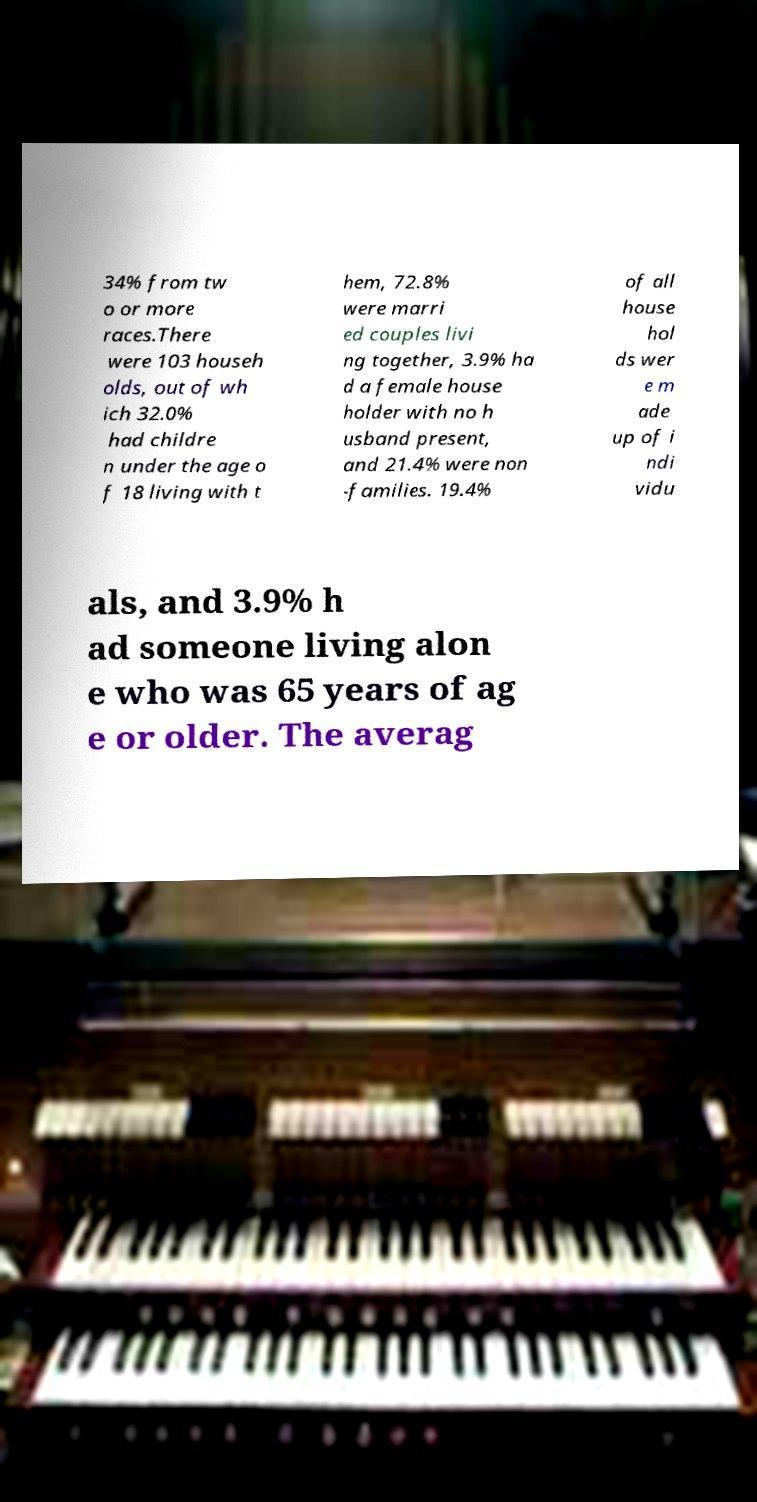Please read and relay the text visible in this image. What does it say? 34% from tw o or more races.There were 103 househ olds, out of wh ich 32.0% had childre n under the age o f 18 living with t hem, 72.8% were marri ed couples livi ng together, 3.9% ha d a female house holder with no h usband present, and 21.4% were non -families. 19.4% of all house hol ds wer e m ade up of i ndi vidu als, and 3.9% h ad someone living alon e who was 65 years of ag e or older. The averag 